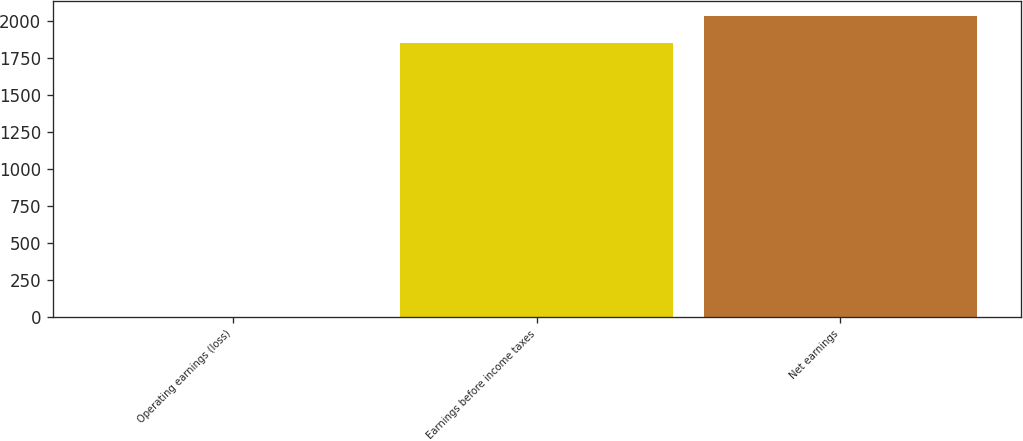Convert chart. <chart><loc_0><loc_0><loc_500><loc_500><bar_chart><fcel>Operating earnings (loss)<fcel>Earnings before income taxes<fcel>Net earnings<nl><fcel>2.5<fcel>1848.7<fcel>2033.32<nl></chart> 